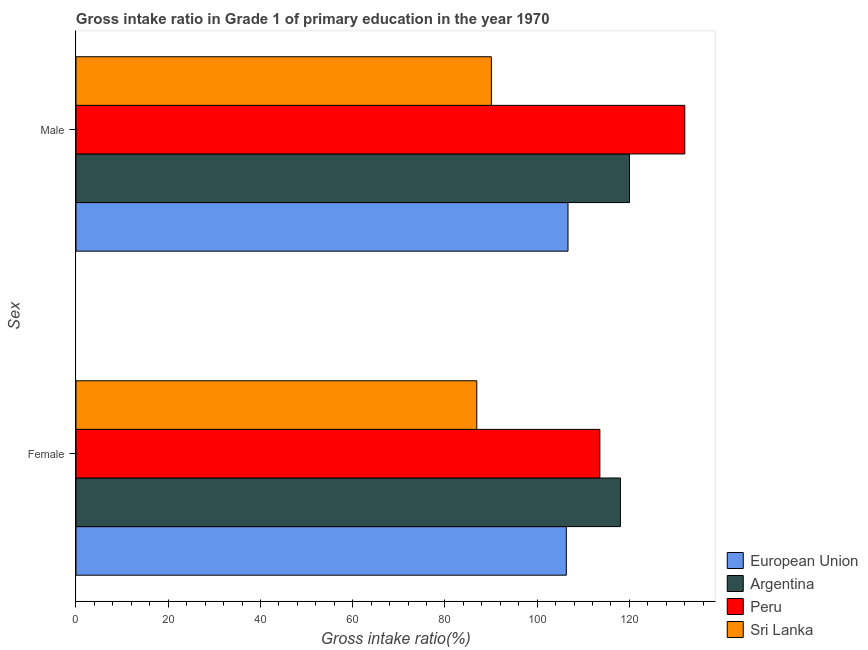How many groups of bars are there?
Provide a succinct answer. 2. Are the number of bars on each tick of the Y-axis equal?
Offer a very short reply. Yes. What is the label of the 2nd group of bars from the top?
Your answer should be very brief. Female. What is the gross intake ratio(male) in Sri Lanka?
Your answer should be compact. 90.07. Across all countries, what is the maximum gross intake ratio(female)?
Make the answer very short. 118.05. Across all countries, what is the minimum gross intake ratio(male)?
Ensure brevity in your answer.  90.07. In which country was the gross intake ratio(female) minimum?
Your response must be concise. Sri Lanka. What is the total gross intake ratio(male) in the graph?
Provide a succinct answer. 448.77. What is the difference between the gross intake ratio(female) in Peru and that in Sri Lanka?
Provide a short and direct response. 26.69. What is the difference between the gross intake ratio(female) in Sri Lanka and the gross intake ratio(male) in Peru?
Keep it short and to the point. -45.1. What is the average gross intake ratio(male) per country?
Keep it short and to the point. 112.19. What is the difference between the gross intake ratio(male) and gross intake ratio(female) in European Union?
Your response must be concise. 0.37. What is the ratio of the gross intake ratio(male) in Argentina to that in Peru?
Keep it short and to the point. 0.91. Is the gross intake ratio(female) in Peru less than that in European Union?
Offer a terse response. No. In how many countries, is the gross intake ratio(female) greater than the average gross intake ratio(female) taken over all countries?
Make the answer very short. 3. What does the 3rd bar from the top in Male represents?
Offer a terse response. Argentina. How many countries are there in the graph?
Your answer should be compact. 4. Are the values on the major ticks of X-axis written in scientific E-notation?
Your answer should be very brief. No. Does the graph contain any zero values?
Give a very brief answer. No. Does the graph contain grids?
Keep it short and to the point. No. Where does the legend appear in the graph?
Offer a very short reply. Bottom right. What is the title of the graph?
Your answer should be compact. Gross intake ratio in Grade 1 of primary education in the year 1970. Does "Belgium" appear as one of the legend labels in the graph?
Ensure brevity in your answer.  No. What is the label or title of the X-axis?
Make the answer very short. Gross intake ratio(%). What is the label or title of the Y-axis?
Provide a short and direct response. Sex. What is the Gross intake ratio(%) in European Union in Female?
Ensure brevity in your answer.  106.32. What is the Gross intake ratio(%) in Argentina in Female?
Offer a terse response. 118.05. What is the Gross intake ratio(%) of Peru in Female?
Offer a very short reply. 113.59. What is the Gross intake ratio(%) of Sri Lanka in Female?
Give a very brief answer. 86.9. What is the Gross intake ratio(%) in European Union in Male?
Provide a short and direct response. 106.68. What is the Gross intake ratio(%) in Argentina in Male?
Offer a terse response. 120.02. What is the Gross intake ratio(%) of Peru in Male?
Keep it short and to the point. 132.01. What is the Gross intake ratio(%) of Sri Lanka in Male?
Offer a terse response. 90.07. Across all Sex, what is the maximum Gross intake ratio(%) in European Union?
Provide a succinct answer. 106.68. Across all Sex, what is the maximum Gross intake ratio(%) in Argentina?
Offer a very short reply. 120.02. Across all Sex, what is the maximum Gross intake ratio(%) of Peru?
Offer a terse response. 132.01. Across all Sex, what is the maximum Gross intake ratio(%) of Sri Lanka?
Provide a succinct answer. 90.07. Across all Sex, what is the minimum Gross intake ratio(%) of European Union?
Your response must be concise. 106.32. Across all Sex, what is the minimum Gross intake ratio(%) in Argentina?
Provide a short and direct response. 118.05. Across all Sex, what is the minimum Gross intake ratio(%) in Peru?
Your answer should be compact. 113.59. Across all Sex, what is the minimum Gross intake ratio(%) in Sri Lanka?
Your answer should be very brief. 86.9. What is the total Gross intake ratio(%) in European Union in the graph?
Your answer should be very brief. 213. What is the total Gross intake ratio(%) of Argentina in the graph?
Give a very brief answer. 238.07. What is the total Gross intake ratio(%) in Peru in the graph?
Your answer should be very brief. 245.6. What is the total Gross intake ratio(%) in Sri Lanka in the graph?
Provide a short and direct response. 176.97. What is the difference between the Gross intake ratio(%) in European Union in Female and that in Male?
Keep it short and to the point. -0.37. What is the difference between the Gross intake ratio(%) in Argentina in Female and that in Male?
Ensure brevity in your answer.  -1.97. What is the difference between the Gross intake ratio(%) of Peru in Female and that in Male?
Provide a succinct answer. -18.41. What is the difference between the Gross intake ratio(%) of Sri Lanka in Female and that in Male?
Make the answer very short. -3.16. What is the difference between the Gross intake ratio(%) of European Union in Female and the Gross intake ratio(%) of Argentina in Male?
Your answer should be very brief. -13.7. What is the difference between the Gross intake ratio(%) of European Union in Female and the Gross intake ratio(%) of Peru in Male?
Provide a short and direct response. -25.69. What is the difference between the Gross intake ratio(%) in European Union in Female and the Gross intake ratio(%) in Sri Lanka in Male?
Offer a terse response. 16.25. What is the difference between the Gross intake ratio(%) of Argentina in Female and the Gross intake ratio(%) of Peru in Male?
Provide a short and direct response. -13.96. What is the difference between the Gross intake ratio(%) of Argentina in Female and the Gross intake ratio(%) of Sri Lanka in Male?
Provide a succinct answer. 27.98. What is the difference between the Gross intake ratio(%) in Peru in Female and the Gross intake ratio(%) in Sri Lanka in Male?
Offer a very short reply. 23.53. What is the average Gross intake ratio(%) in European Union per Sex?
Ensure brevity in your answer.  106.5. What is the average Gross intake ratio(%) in Argentina per Sex?
Make the answer very short. 119.03. What is the average Gross intake ratio(%) of Peru per Sex?
Your answer should be very brief. 122.8. What is the average Gross intake ratio(%) of Sri Lanka per Sex?
Give a very brief answer. 88.49. What is the difference between the Gross intake ratio(%) of European Union and Gross intake ratio(%) of Argentina in Female?
Offer a very short reply. -11.73. What is the difference between the Gross intake ratio(%) of European Union and Gross intake ratio(%) of Peru in Female?
Provide a succinct answer. -7.28. What is the difference between the Gross intake ratio(%) in European Union and Gross intake ratio(%) in Sri Lanka in Female?
Make the answer very short. 19.41. What is the difference between the Gross intake ratio(%) in Argentina and Gross intake ratio(%) in Peru in Female?
Provide a short and direct response. 4.46. What is the difference between the Gross intake ratio(%) of Argentina and Gross intake ratio(%) of Sri Lanka in Female?
Your answer should be compact. 31.15. What is the difference between the Gross intake ratio(%) of Peru and Gross intake ratio(%) of Sri Lanka in Female?
Provide a short and direct response. 26.69. What is the difference between the Gross intake ratio(%) in European Union and Gross intake ratio(%) in Argentina in Male?
Keep it short and to the point. -13.34. What is the difference between the Gross intake ratio(%) in European Union and Gross intake ratio(%) in Peru in Male?
Your answer should be very brief. -25.33. What is the difference between the Gross intake ratio(%) of European Union and Gross intake ratio(%) of Sri Lanka in Male?
Keep it short and to the point. 16.62. What is the difference between the Gross intake ratio(%) of Argentina and Gross intake ratio(%) of Peru in Male?
Make the answer very short. -11.99. What is the difference between the Gross intake ratio(%) in Argentina and Gross intake ratio(%) in Sri Lanka in Male?
Provide a succinct answer. 29.95. What is the difference between the Gross intake ratio(%) of Peru and Gross intake ratio(%) of Sri Lanka in Male?
Give a very brief answer. 41.94. What is the ratio of the Gross intake ratio(%) of Argentina in Female to that in Male?
Provide a short and direct response. 0.98. What is the ratio of the Gross intake ratio(%) of Peru in Female to that in Male?
Provide a short and direct response. 0.86. What is the ratio of the Gross intake ratio(%) in Sri Lanka in Female to that in Male?
Offer a very short reply. 0.96. What is the difference between the highest and the second highest Gross intake ratio(%) in European Union?
Your answer should be compact. 0.37. What is the difference between the highest and the second highest Gross intake ratio(%) of Argentina?
Your answer should be very brief. 1.97. What is the difference between the highest and the second highest Gross intake ratio(%) of Peru?
Provide a succinct answer. 18.41. What is the difference between the highest and the second highest Gross intake ratio(%) in Sri Lanka?
Give a very brief answer. 3.16. What is the difference between the highest and the lowest Gross intake ratio(%) of European Union?
Your response must be concise. 0.37. What is the difference between the highest and the lowest Gross intake ratio(%) in Argentina?
Provide a succinct answer. 1.97. What is the difference between the highest and the lowest Gross intake ratio(%) of Peru?
Your answer should be compact. 18.41. What is the difference between the highest and the lowest Gross intake ratio(%) of Sri Lanka?
Offer a very short reply. 3.16. 